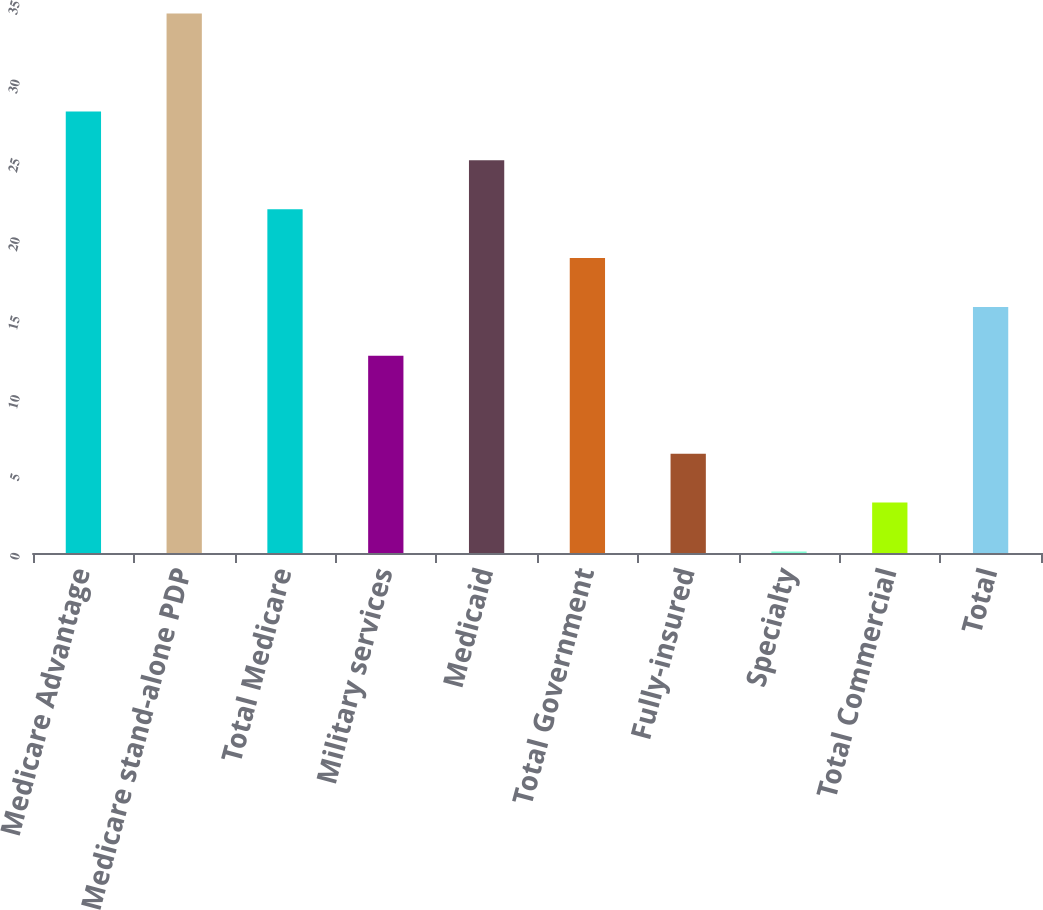Convert chart to OTSL. <chart><loc_0><loc_0><loc_500><loc_500><bar_chart><fcel>Medicare Advantage<fcel>Medicare stand-alone PDP<fcel>Total Medicare<fcel>Military services<fcel>Medicaid<fcel>Total Government<fcel>Fully-insured<fcel>Specialty<fcel>Total Commercial<fcel>Total<nl><fcel>28<fcel>34.2<fcel>21.8<fcel>12.5<fcel>24.9<fcel>18.7<fcel>6.3<fcel>0.1<fcel>3.2<fcel>15.6<nl></chart> 